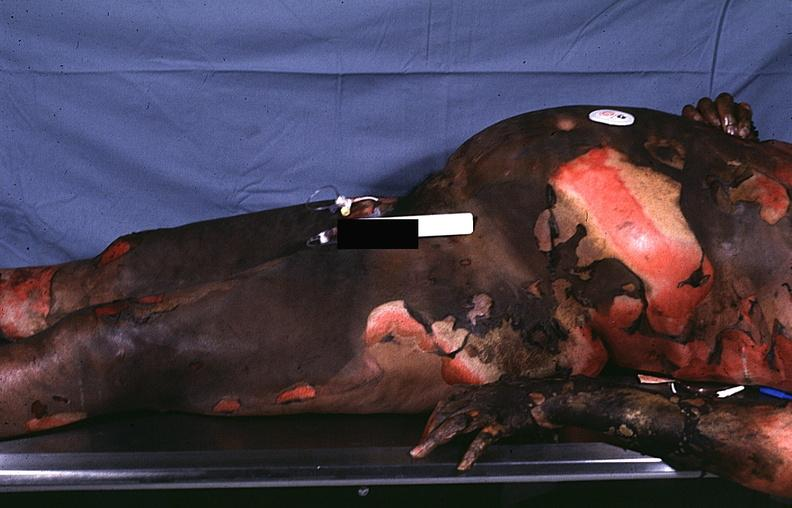what burn?
Answer the question using a single word or phrase. Thermal 